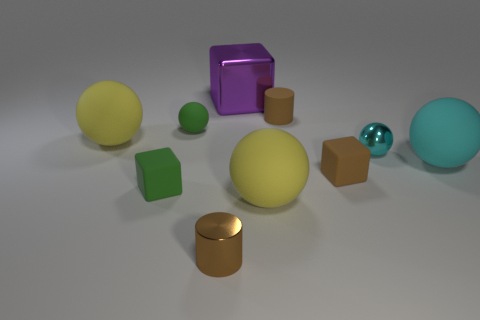What number of small rubber blocks are the same color as the tiny shiny cylinder?
Your answer should be compact. 1. How many tiny rubber cubes are right of the purple thing and on the left side of the small matte ball?
Provide a short and direct response. 0. How many things are tiny green things that are left of the tiny green rubber ball or large things that are left of the large cyan ball?
Your response must be concise. 4. How many other objects are the same shape as the cyan metal thing?
Your answer should be very brief. 4. Does the metallic object that is behind the green rubber ball have the same color as the tiny metal sphere?
Offer a very short reply. No. How many other objects are there of the same size as the purple metal thing?
Offer a terse response. 3. Are the green sphere and the large cyan ball made of the same material?
Give a very brief answer. Yes. What color is the shiny object that is in front of the yellow rubber thing that is right of the large purple thing?
Offer a terse response. Brown. There is a green thing that is the same shape as the big cyan thing; what size is it?
Provide a succinct answer. Small. Is the color of the small shiny cylinder the same as the small rubber cylinder?
Ensure brevity in your answer.  Yes. 